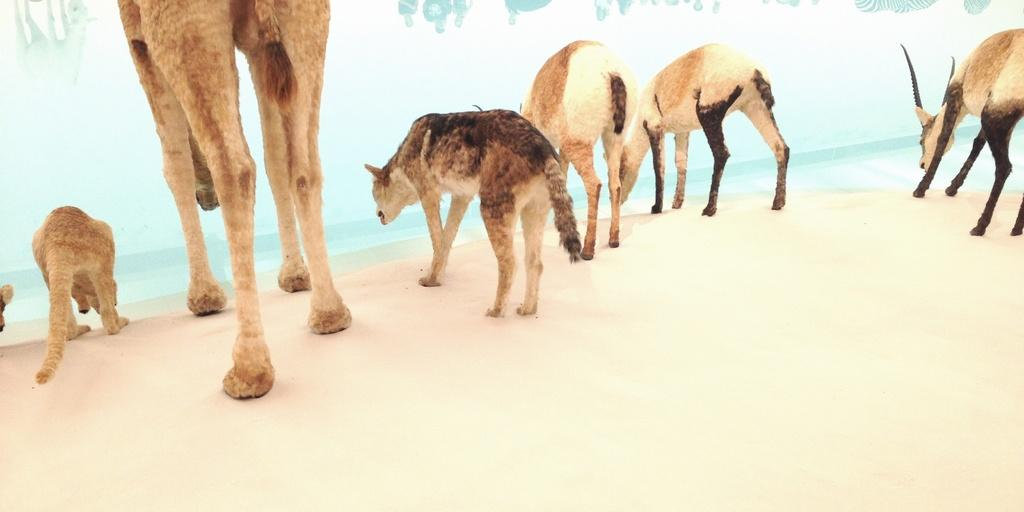What type of objects are standing in the image? There are artificial animals standing in the image. What is present at the bottom of the image? There is sand at the bottom of the image. What can be seen in the water in the image? There is water visible in the image, and there are reflections of a group of people and a zebra in the water. Where is the maid standing in the image? There is no maid present in the image. What type of thrill can be experienced by the artificial animals in the image? The artificial animals are not capable of experiencing thrill, as they are inanimate objects. 